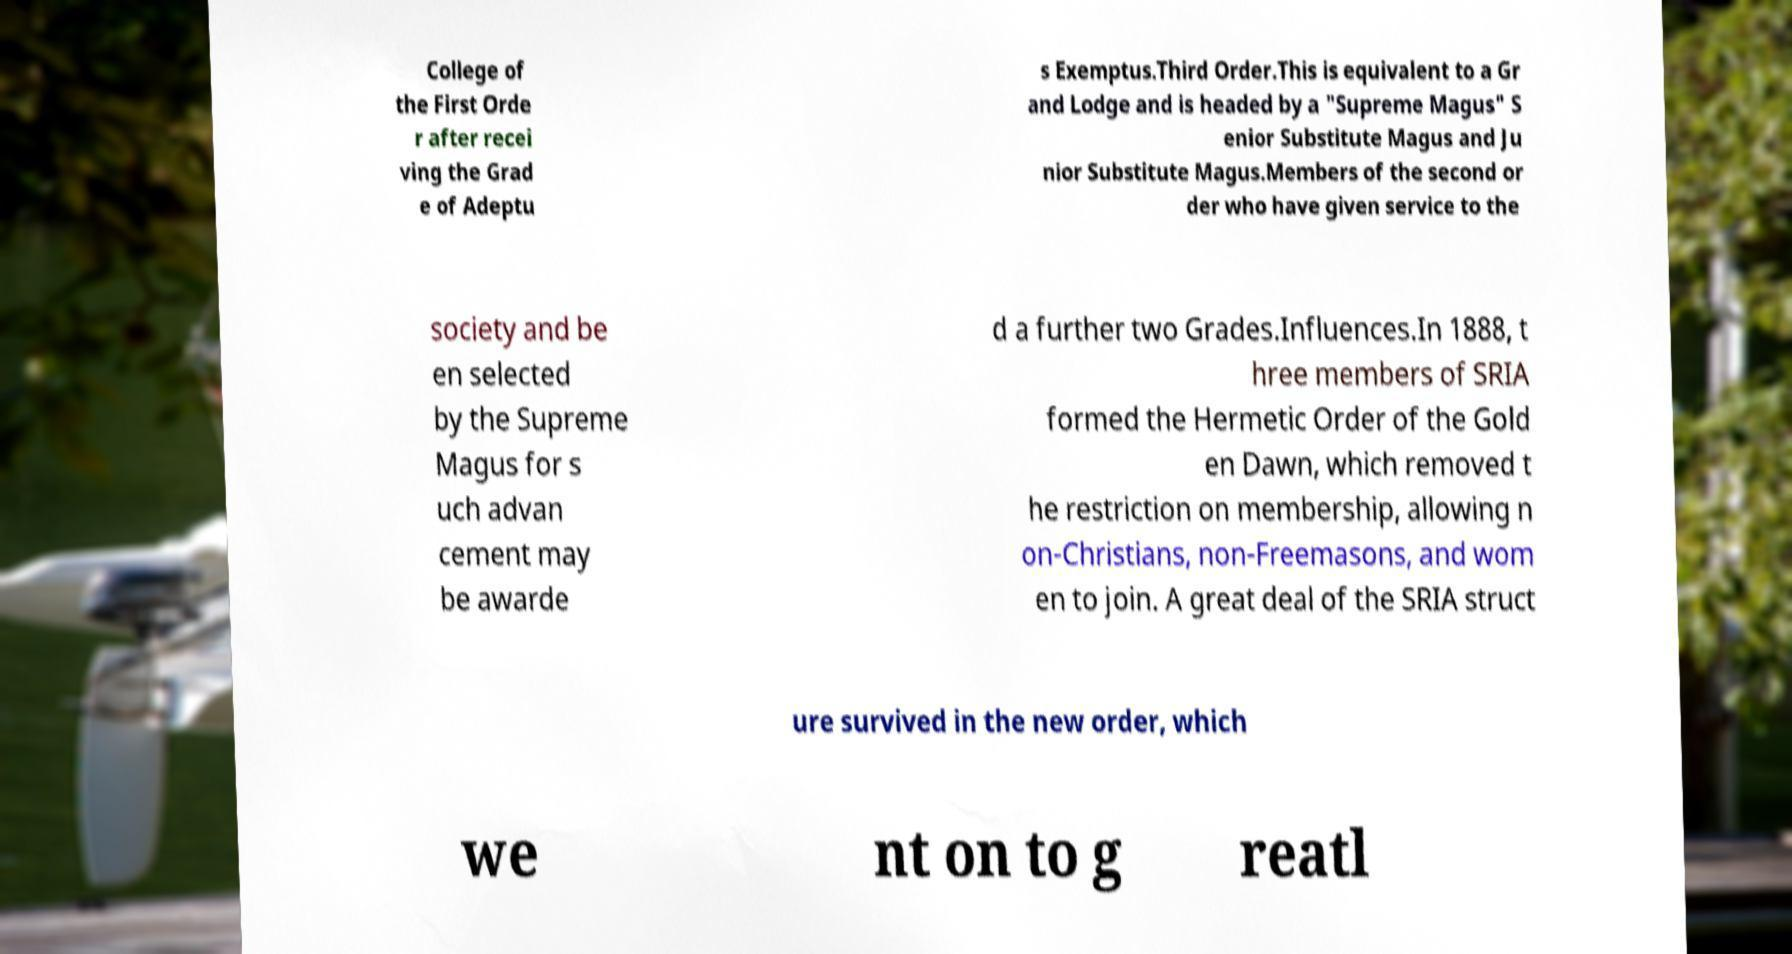What messages or text are displayed in this image? I need them in a readable, typed format. College of the First Orde r after recei ving the Grad e of Adeptu s Exemptus.Third Order.This is equivalent to a Gr and Lodge and is headed by a "Supreme Magus" S enior Substitute Magus and Ju nior Substitute Magus.Members of the second or der who have given service to the society and be en selected by the Supreme Magus for s uch advan cement may be awarde d a further two Grades.Influences.In 1888, t hree members of SRIA formed the Hermetic Order of the Gold en Dawn, which removed t he restriction on membership, allowing n on-Christians, non-Freemasons, and wom en to join. A great deal of the SRIA struct ure survived in the new order, which we nt on to g reatl 